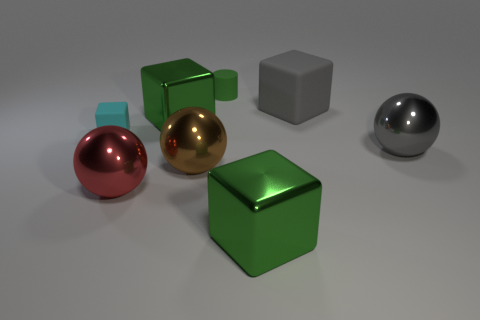Are there any other things that have the same color as the small rubber cube?
Offer a terse response. No. What is the thing behind the matte cube to the right of the small green matte object made of?
Your response must be concise. Rubber. Is the small cyan object made of the same material as the tiny object that is right of the brown sphere?
Offer a very short reply. Yes. What number of things are things that are in front of the big brown shiny object or big yellow metal balls?
Make the answer very short. 2. Are there any cylinders of the same color as the tiny rubber cube?
Keep it short and to the point. No. There is a small cyan matte thing; does it have the same shape as the red metal thing that is on the left side of the rubber cylinder?
Provide a short and direct response. No. What number of cubes are both behind the large red object and right of the red metal ball?
Your answer should be very brief. 2. There is a small cyan object that is the same shape as the big gray matte thing; what material is it?
Keep it short and to the point. Rubber. There is a matte cube that is to the left of the large green metal cube that is in front of the cyan matte block; what size is it?
Provide a succinct answer. Small. Are there any blue matte blocks?
Offer a very short reply. No. 